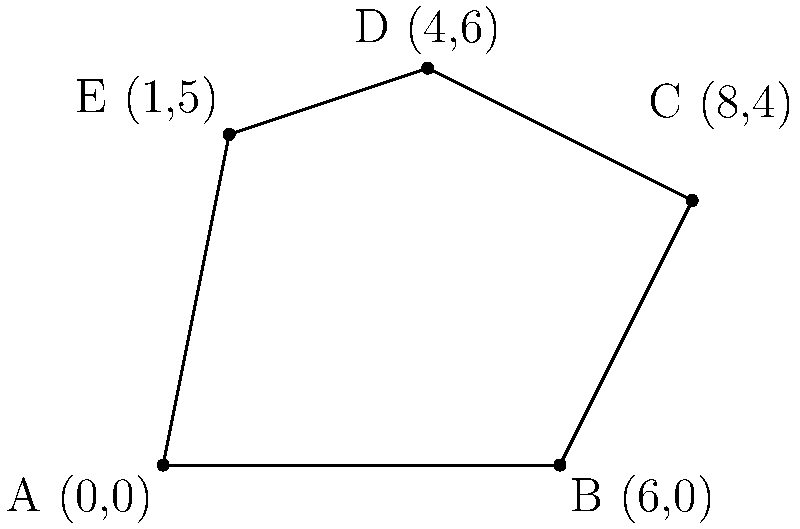A historical district in an urban river area has an irregular pentagonal shape. The coordinates of its vertices are A(0,0), B(6,0), C(8,4), D(4,6), and E(1,5). Calculate the area of this historical district using coordinate geometry methods. To calculate the area of this irregular pentagon, we can use the Shoelace formula (also known as the surveyor's formula). The steps are as follows:

1) The Shoelace formula for a polygon with vertices $(x_1, y_1), (x_2, y_2), ..., (x_n, y_n)$ is:

   Area = $\frac{1}{2}|x_1y_2 + x_2y_3 + ... + x_ny_1 - y_1x_2 - y_2x_3 - ... - y_nx_1|$

2) Substituting our coordinates:
   A(0,0), B(6,0), C(8,4), D(4,6), E(1,5)

3) Applying the formula:

   Area = $\frac{1}{2}|(0 \cdot 0 + 6 \cdot 4 + 8 \cdot 6 + 4 \cdot 5 + 1 \cdot 0) - (0 \cdot 6 + 0 \cdot 8 + 4 \cdot 4 + 6 \cdot 1 + 5 \cdot 0)|$

4) Simplifying:

   Area = $\frac{1}{2}|(0 + 24 + 48 + 20 + 0) - (0 + 0 + 16 + 6 + 0)|$
   
   Area = $\frac{1}{2}|92 - 22|$
   
   Area = $\frac{1}{2}(70)$
   
   Area = 35

Therefore, the area of the historical district is 35 square units.
Answer: 35 square units 